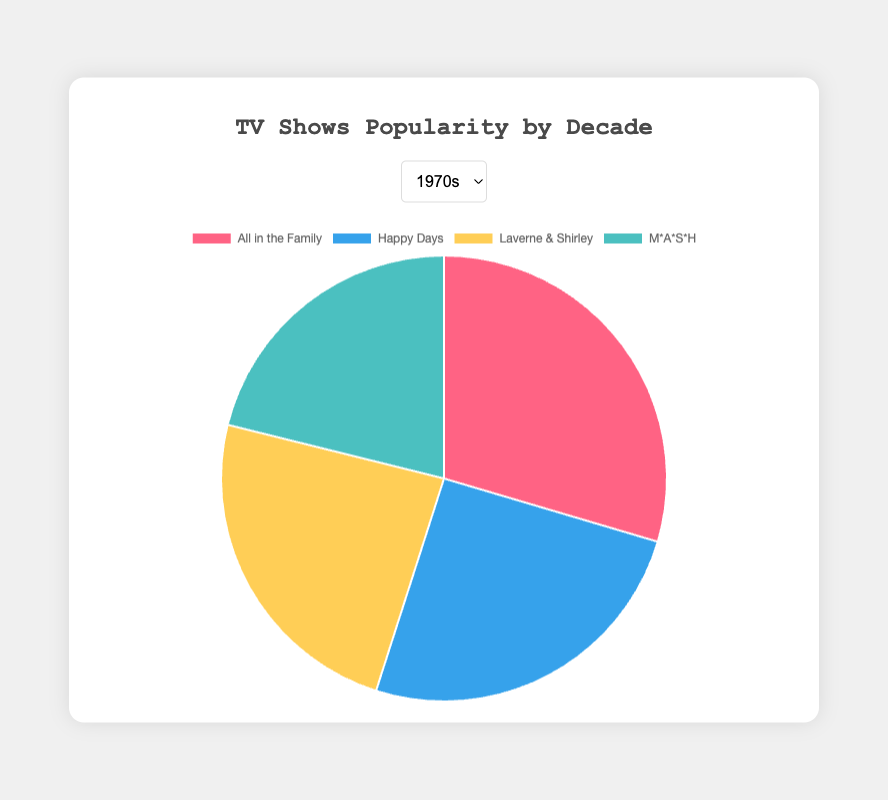What is the show with the highest percentage share in the 1980s? Look at the slice of the pie chart for the 1980s decade to determine which show has the largest share. "The Cosby Show" has the highest percentage share at 25%.
Answer: The Cosby Show What is the combined percentage share of "Friends" and "ER" in the 1990s? Find the percentage shares for "Friends" (22%) and "ER" (21%) on the 1990s pie chart, then add them together. 22% + 21% = 43%.
Answer: 43% Which decade has the show with the highest individual percentage share? Compare the highest individual percentage shares from each pie chart: 1970s ("All in the Family" 21%), 1980s ("The Cosby Show" 25%), 1990s ("Seinfeld" 24%), 2000s ("CSI: Crime Scene Investigation" 23%). The 1980s has "The Cosby Show" with the highest share at 25%.
Answer: 1980s Between "M*A*S*H" and "Cheers", which show has a higher percentage share, and by how much? Compare the percentage shares of "M*A*S*H" (15%) from the 1970s and "Cheers" (19%) from the 1980s. Calculate the difference: 19% - 15% = 4%.
Answer: Cheers, by 4% Which show in the 2000s has a lower percentage share than "Laverne & Shirley" from the 1970s? Compare "Laverne & Shirley" (17%) from the 1970s with the shows in the 2000s: "CSI: Crime Scene Investigation" (23%), "American Idol" (22%), "Survivor" (20%), and "The West Wing" (18%). None of these shows have a lower share than "Laverne & Shirley".
Answer: None What is the average percentage share of the shows in the 1990s? Sum the percentage shares of the shows in the 1990s: "Seinfeld" (24%) + "Friends" (22%) + "ER" (21%) + "The X-Files" (19%) = 86%, then divide by the number of shows (4). 86% / 4 = 21.5%.
Answer: 21.5% Which decade has the smallest total share among its top four shows? Calculate the total share for each decade's top four shows: 
1970s: 21% + 18% + 17% + 15% = 71%
1980s: 25% + 20% + 19% + 16% = 80%
1990s: 24% + 22% + 21% + 19% = 86%
2000s: 23% + 22% + 20% + 18% = 83%
The 1970s has the smallest total share at 71%.
Answer: 1970s 